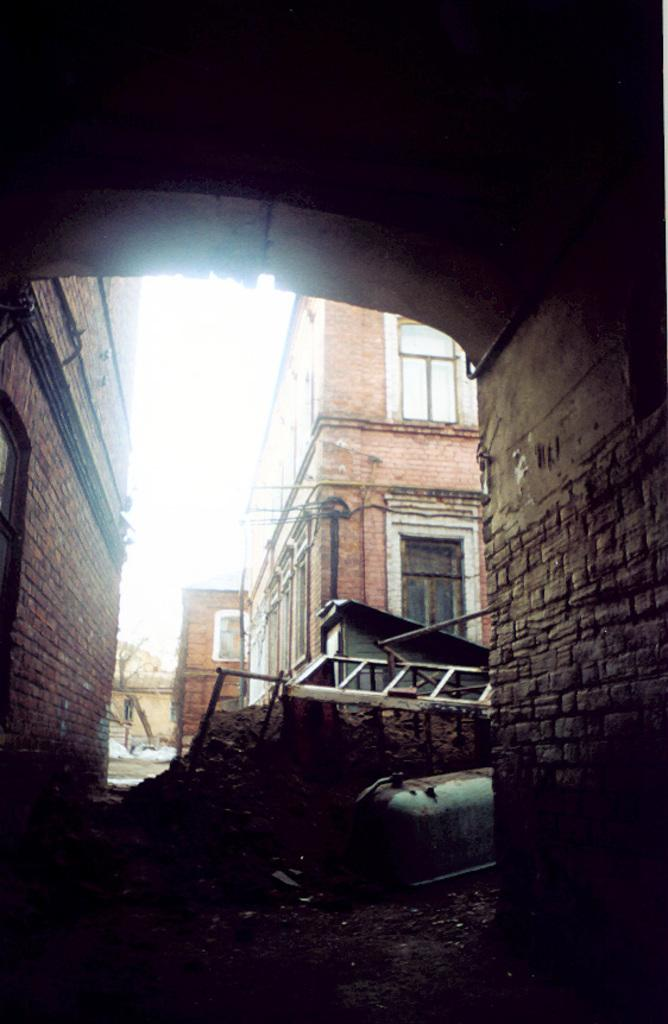What type of object is located on the ground in the image? There is a metal object placed on the ground in the image. What can be seen in the background of the image? There are buildings in the background of the image. What is visible at the top of the image? The sky is visible at the top of the image. What type of system is being used to control the flag in the image? There is no flag present in the image, so it is not possible to determine if a system is being used to control it. 